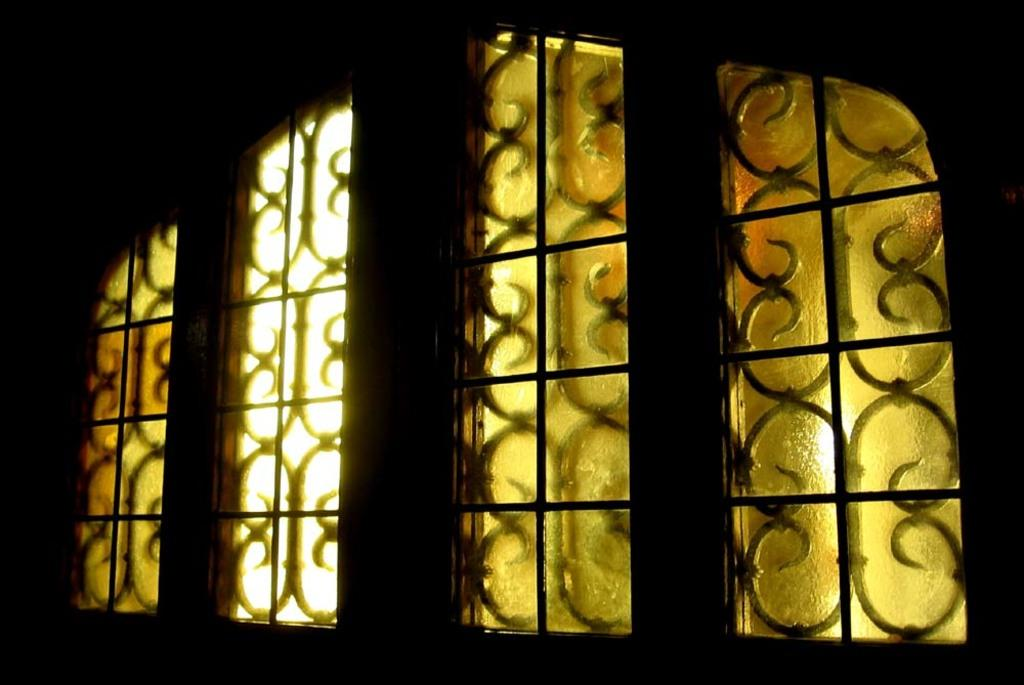What can be seen in the picture that allows light to enter a room? There is a window in the picture that allows light to enter a room. What material makes up the window's frame? The window has both a wooden frame and an iron frame. What else can be seen in the picture besides the window? There is a wall in the picture. What type of furniture can be seen running through the window in the image? There is no furniture running through the window in the image, as the window is stationary and there is no indication of any furniture in the image. 